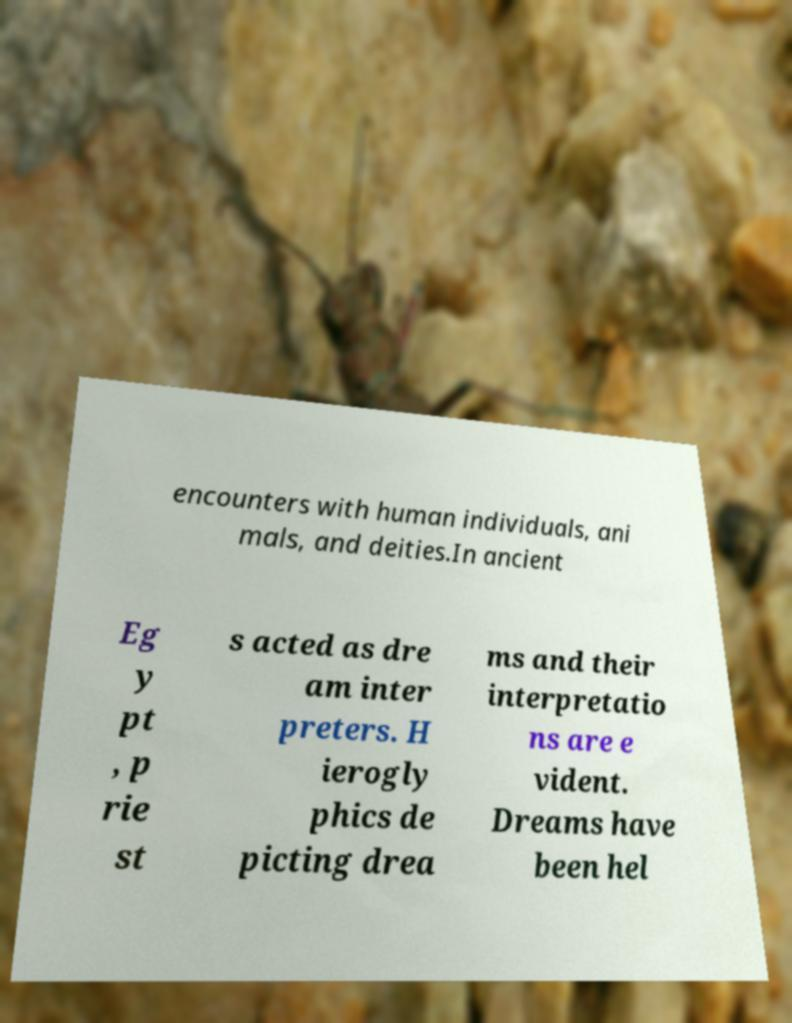Could you assist in decoding the text presented in this image and type it out clearly? encounters with human individuals, ani mals, and deities.In ancient Eg y pt , p rie st s acted as dre am inter preters. H ierogly phics de picting drea ms and their interpretatio ns are e vident. Dreams have been hel 